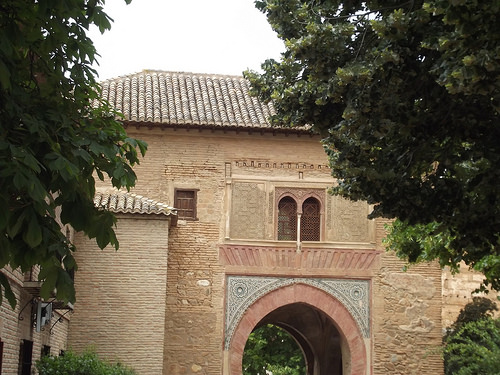<image>
Is the roof behind the tree? Yes. From this viewpoint, the roof is positioned behind the tree, with the tree partially or fully occluding the roof. 